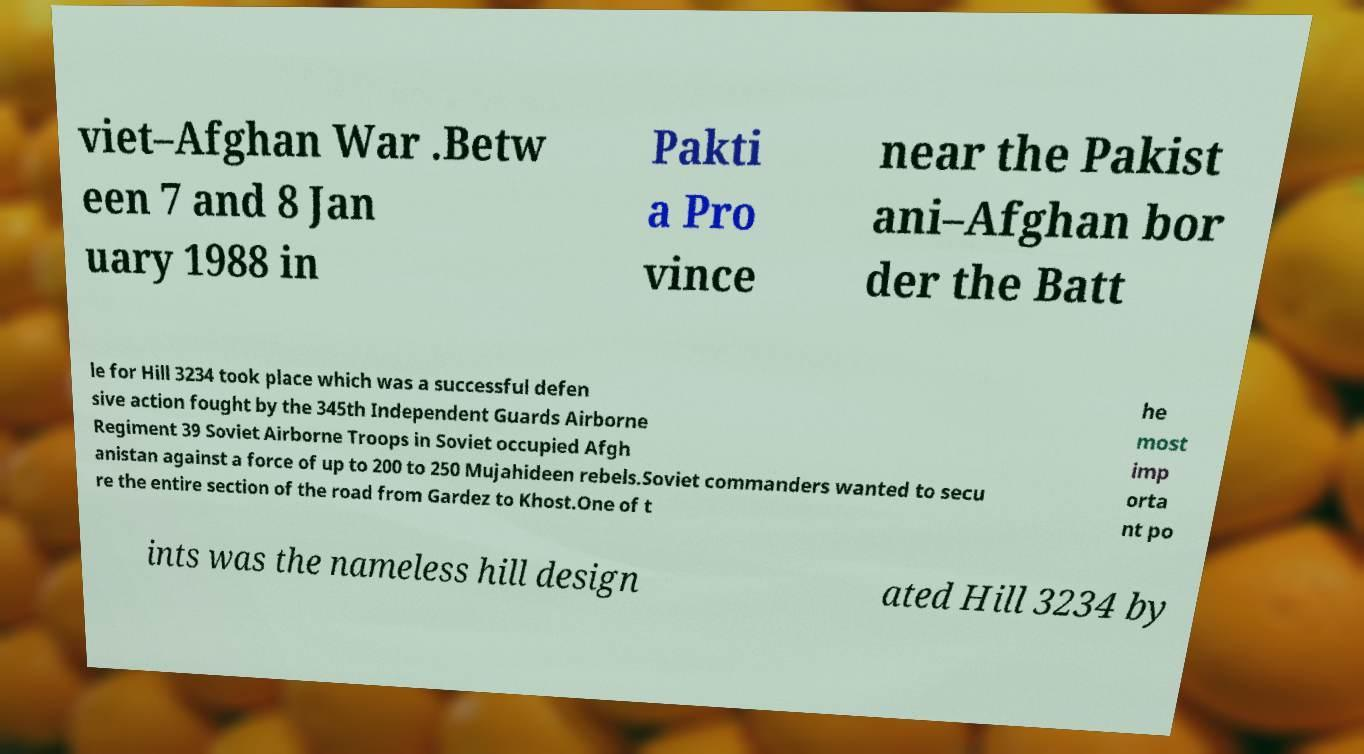What messages or text are displayed in this image? I need them in a readable, typed format. viet–Afghan War .Betw een 7 and 8 Jan uary 1988 in Pakti a Pro vince near the Pakist ani–Afghan bor der the Batt le for Hill 3234 took place which was a successful defen sive action fought by the 345th Independent Guards Airborne Regiment 39 Soviet Airborne Troops in Soviet occupied Afgh anistan against a force of up to 200 to 250 Mujahideen rebels.Soviet commanders wanted to secu re the entire section of the road from Gardez to Khost.One of t he most imp orta nt po ints was the nameless hill design ated Hill 3234 by 